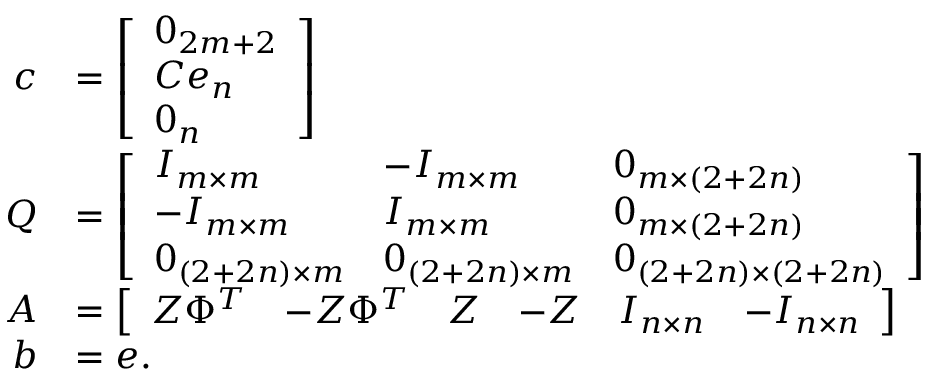Convert formula to latex. <formula><loc_0><loc_0><loc_500><loc_500>\begin{array} { r l } { c } & { = \left [ \begin{array} { l } { 0 _ { 2 m + 2 } } \\ { C e _ { n } } \\ { 0 _ { n } } \end{array} \right ] } \\ { Q } & { = \left [ \begin{array} { l l l } { I _ { m \times m } } & { - I _ { m \times m } } & { 0 _ { m \times ( 2 + 2 n ) } } \\ { - I _ { m \times m } } & { I _ { m \times m } } & { 0 _ { m \times ( 2 + 2 n ) } } \\ { 0 _ { ( 2 + 2 n ) \times m } } & { 0 _ { ( 2 + 2 n ) \times m } } & { 0 _ { ( 2 + 2 n ) \times ( 2 + 2 n ) } } \end{array} \right ] } \\ { A } & { = \left [ \begin{array} { l l l l l l } { Z \Phi ^ { T } } & { - Z \Phi ^ { T } } & { Z } & { - Z } & { I _ { n \times n } } & { - I _ { n \times n } } \end{array} \right ] } \\ { b } & { = e . } \end{array}</formula> 